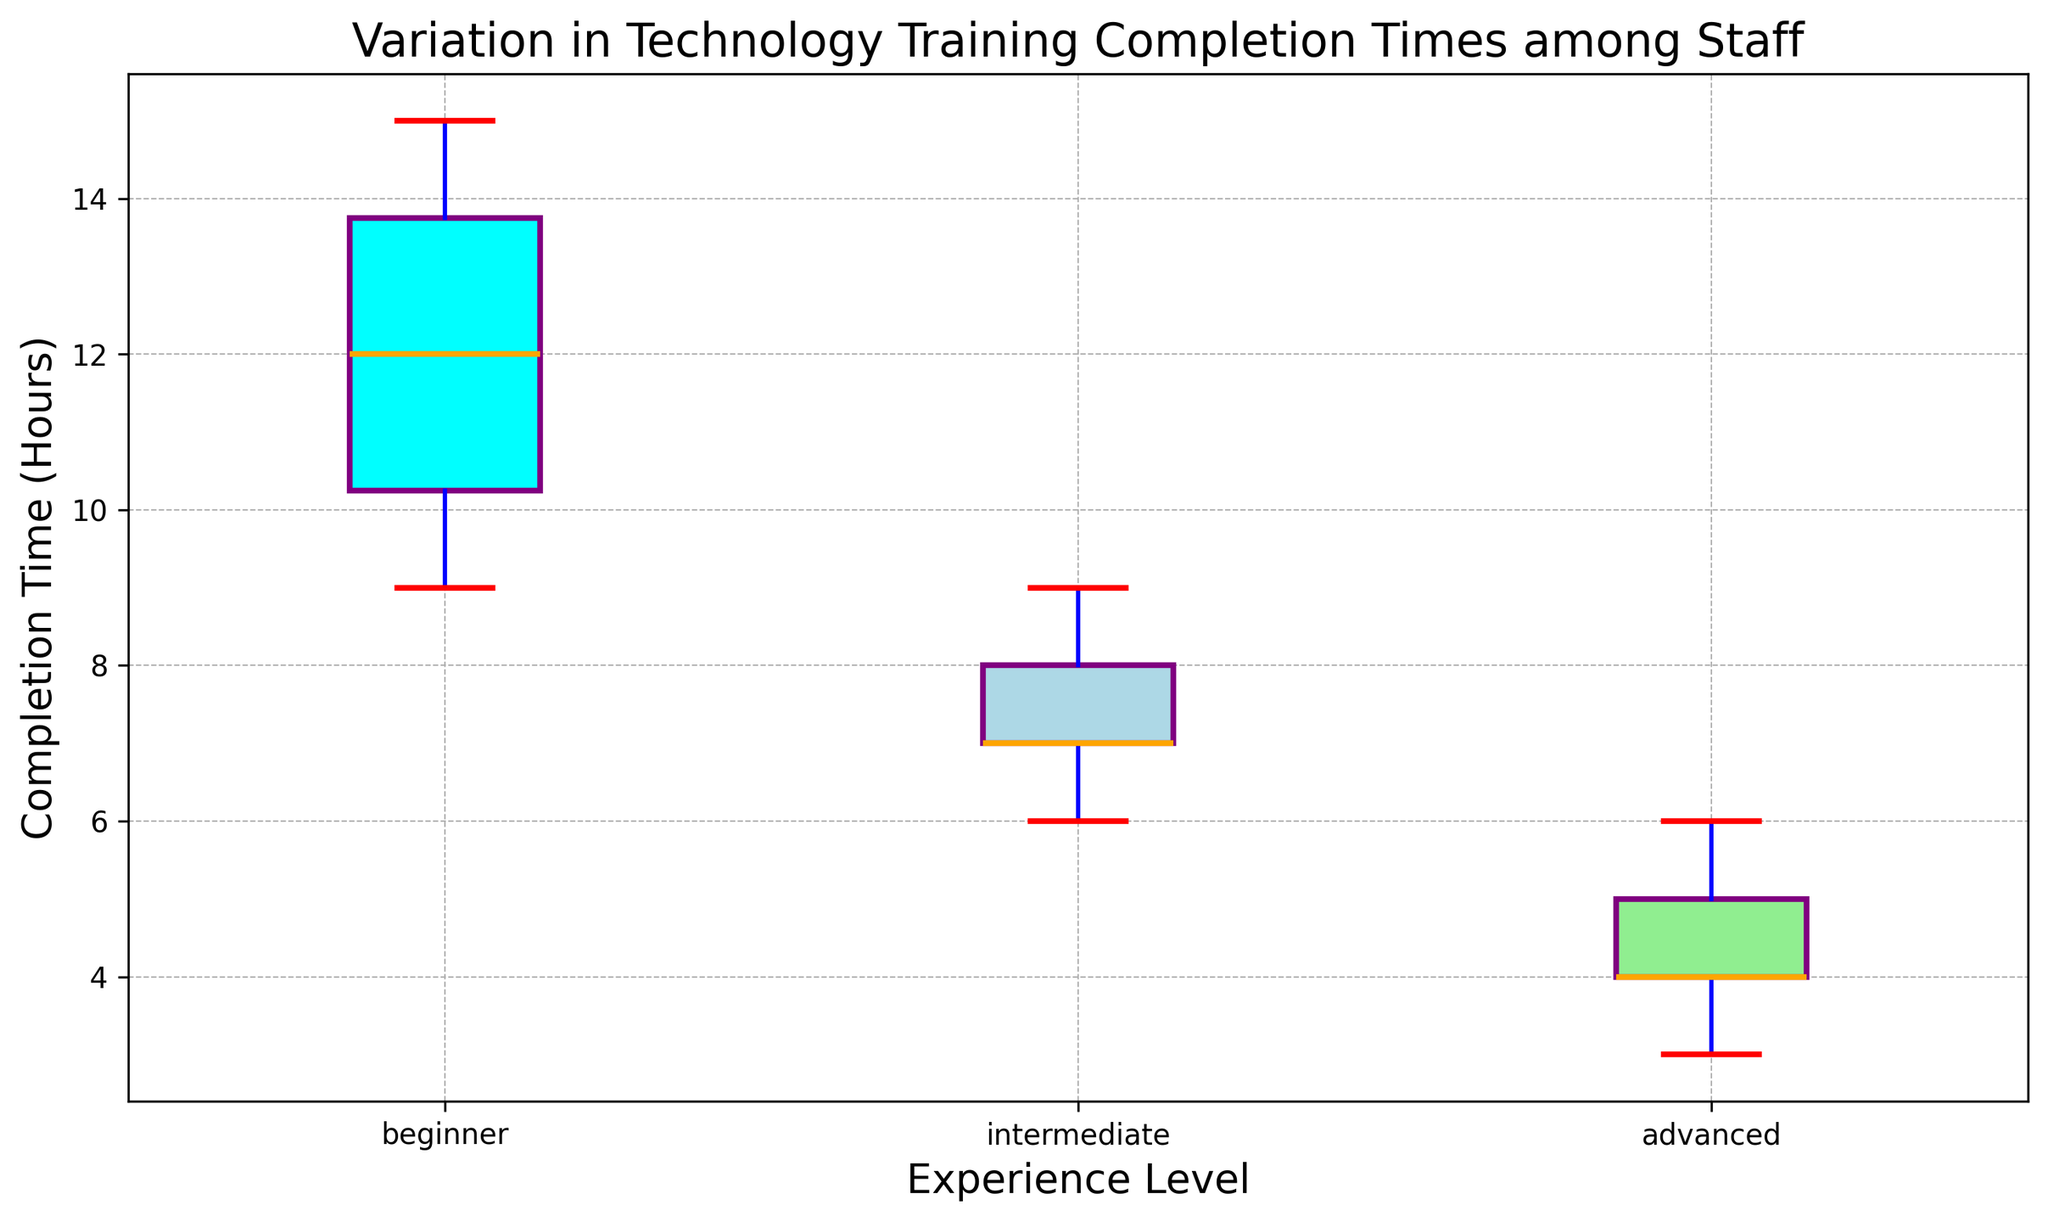How does the median completion time for beginners compare to intermediates? The median line for beginners is higher than the median line for intermediates, indicating that beginners take more time to complete the training on average.
Answer: Beginners take more time Which experience level has the shortest median completion time? The boxplot for the advanced group has the lowest median line compared to beginners and intermediates.
Answer: Advanced What's the range of completion times for beginners? The range of completion times can be found by looking at the difference between the top and bottom whiskers of the beginners' boxplot. The whiskers extend from 9 hours to 15 hours, so the range is 15 - 9 hours.
Answer: 6 hours Is there any overlap in the whiskers between intermediates and advanced staff? The whiskers for intermediates extend from 6 to 9 hours, while the whiskers for advanced staff extend from 3 to 6 hours. Since 6 hours appear in both, there is an overlap at 6 hours.
Answer: Yes, at 6 hours How do the color differences help in distinguishing experience levels? The boxplots are colored differently: cyan for beginners, light blue for intermediates, and light green for advanced. These colors help to visually distinguish between the different experience levels.
Answer: Different colors for each level What is the upper quartile value for the advanced group? The upper quartile, or the top of the box, represents the 75th percentile. For the advanced group, this line is at 5 hours.
Answer: 5 hours Which experience level shows the widest range of completion times and how can you tell? The beginners' boxplot has the widest range, measured from the lowest to the highest whisker (9 to 15 hours), making it 6 hours. The intermediate and advanced groups have ranges of 3 hours each (6 to 9 hours and 3 to 6 hours, respectively).
Answer: Beginners, 6 hours Which group has the most consistent (least variable) completion times? The group with the most consistent completion times has the shortest boxplot and whisker range. The advanced group has the smallest range (3 to 6 hours), implying it is the most consistent.
Answer: Advanced What can you infer from the median completion times about staff experience levels and training efficiency? The median completion times decrease as experience levels increase: beginners take the longest, intermediates less, and advanced the least time. This suggests that more experienced staff complete training more efficiently.
Answer: More experience, more efficiency Are there any outliers for the beginner group and what does this indicate? There are no marked outliers (green markers) for the beginner group. This indicates that the completion times for beginners are relatively consistent within the observed range.
Answer: No outliers 